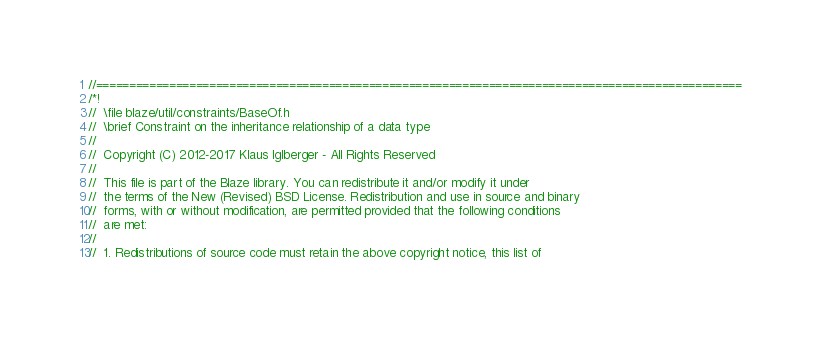Convert code to text. <code><loc_0><loc_0><loc_500><loc_500><_C_>//=================================================================================================
/*!
//  \file blaze/util/constraints/BaseOf.h
//  \brief Constraint on the inheritance relationship of a data type
//
//  Copyright (C) 2012-2017 Klaus Iglberger - All Rights Reserved
//
//  This file is part of the Blaze library. You can redistribute it and/or modify it under
//  the terms of the New (Revised) BSD License. Redistribution and use in source and binary
//  forms, with or without modification, are permitted provided that the following conditions
//  are met:
//
//  1. Redistributions of source code must retain the above copyright notice, this list of</code> 